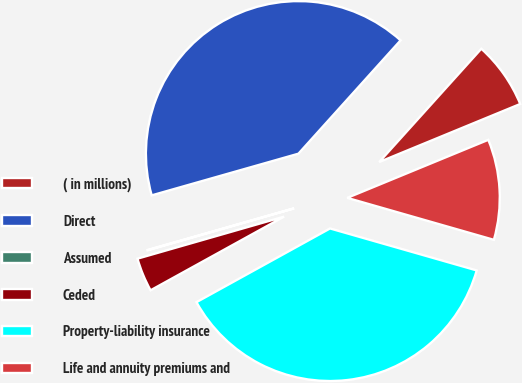Convert chart. <chart><loc_0><loc_0><loc_500><loc_500><pie_chart><fcel>( in millions)<fcel>Direct<fcel>Assumed<fcel>Ceded<fcel>Property-liability insurance<fcel>Life and annuity premiums and<nl><fcel>7.11%<fcel>41.08%<fcel>0.04%<fcel>3.58%<fcel>37.54%<fcel>10.65%<nl></chart> 